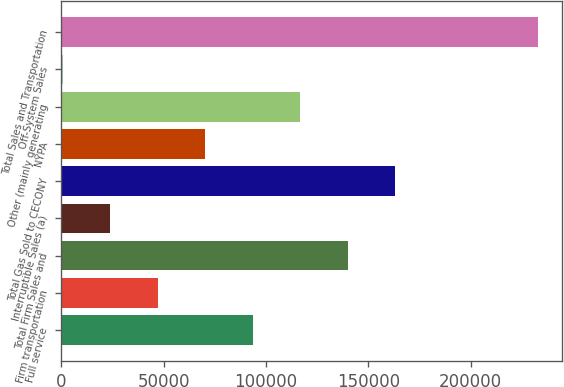Convert chart. <chart><loc_0><loc_0><loc_500><loc_500><bar_chart><fcel>Full service<fcel>Firm transportation<fcel>Total Firm Sales and<fcel>Interruptible Sales (a)<fcel>Total Gas Sold to CECONY<fcel>NYPA<fcel>Other (mainly generating<fcel>Off-System Sales<fcel>Total Sales and Transportation<nl><fcel>93605.4<fcel>47148.2<fcel>140063<fcel>23919.6<fcel>163291<fcel>70376.8<fcel>116834<fcel>691<fcel>232977<nl></chart> 